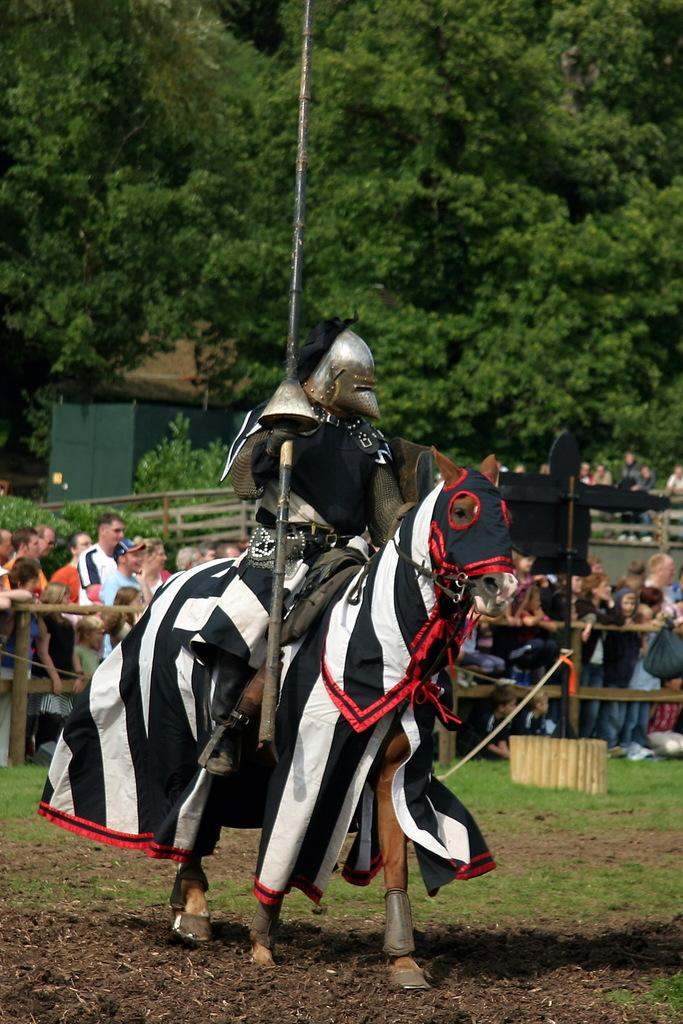What type of vegetation can be seen in the background of the image? There are trees in the background of the image. What is surrounding the people in the image? There is a fence around the people. What is the man in the image doing? The man is sitting on a horse. What type of ground surface is visible at the bottom portion of the image? Soil and grass are present at the bottom portion of the image. What type of comb is the man using on the horse's mane in the image? There is no comb present in the image; the man is simply sitting on the horse. Where is the desk located in the image? There is no desk present in the image. 